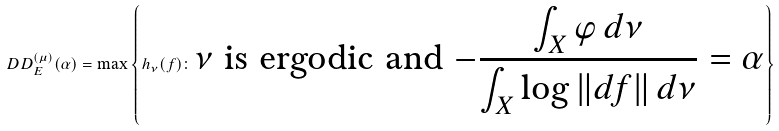<formula> <loc_0><loc_0><loc_500><loc_500>\ D D _ { E } ^ { ( \mu ) } ( \alpha ) = \max \left \{ h _ { \nu } ( f ) \colon \text {$\nu$ is ergodic and $-\frac{\int_{X}\varphi \,d\nu}{\int_{X}\log\| df\|\,d\nu}=\alpha$} \right \}</formula> 